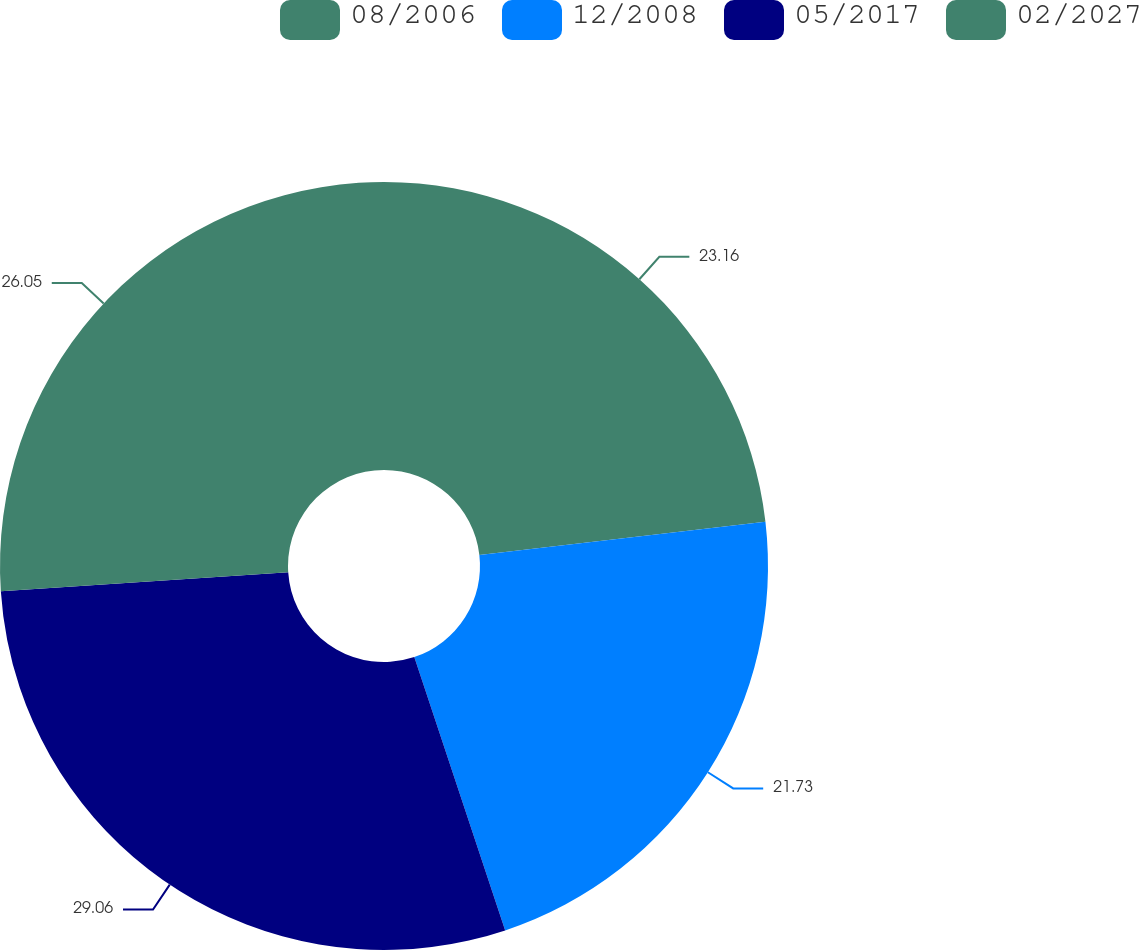Convert chart to OTSL. <chart><loc_0><loc_0><loc_500><loc_500><pie_chart><fcel>08/2006<fcel>12/2008<fcel>05/2017<fcel>02/2027<nl><fcel>23.16%<fcel>21.73%<fcel>29.06%<fcel>26.05%<nl></chart> 